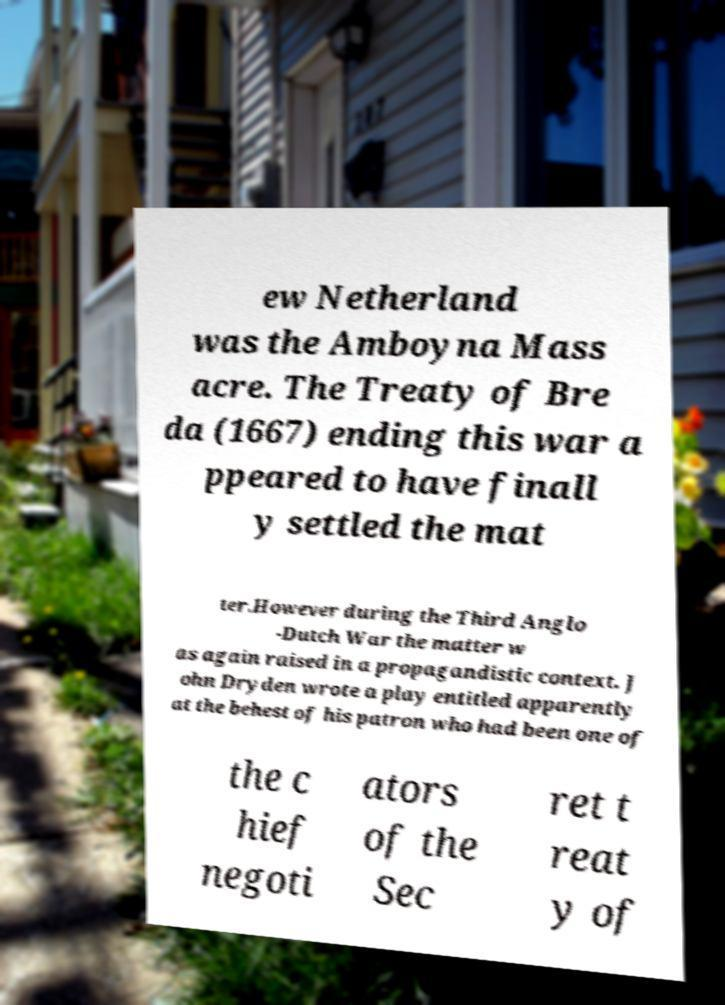I need the written content from this picture converted into text. Can you do that? ew Netherland was the Amboyna Mass acre. The Treaty of Bre da (1667) ending this war a ppeared to have finall y settled the mat ter.However during the Third Anglo -Dutch War the matter w as again raised in a propagandistic context. J ohn Dryden wrote a play entitled apparently at the behest of his patron who had been one of the c hief negoti ators of the Sec ret t reat y of 